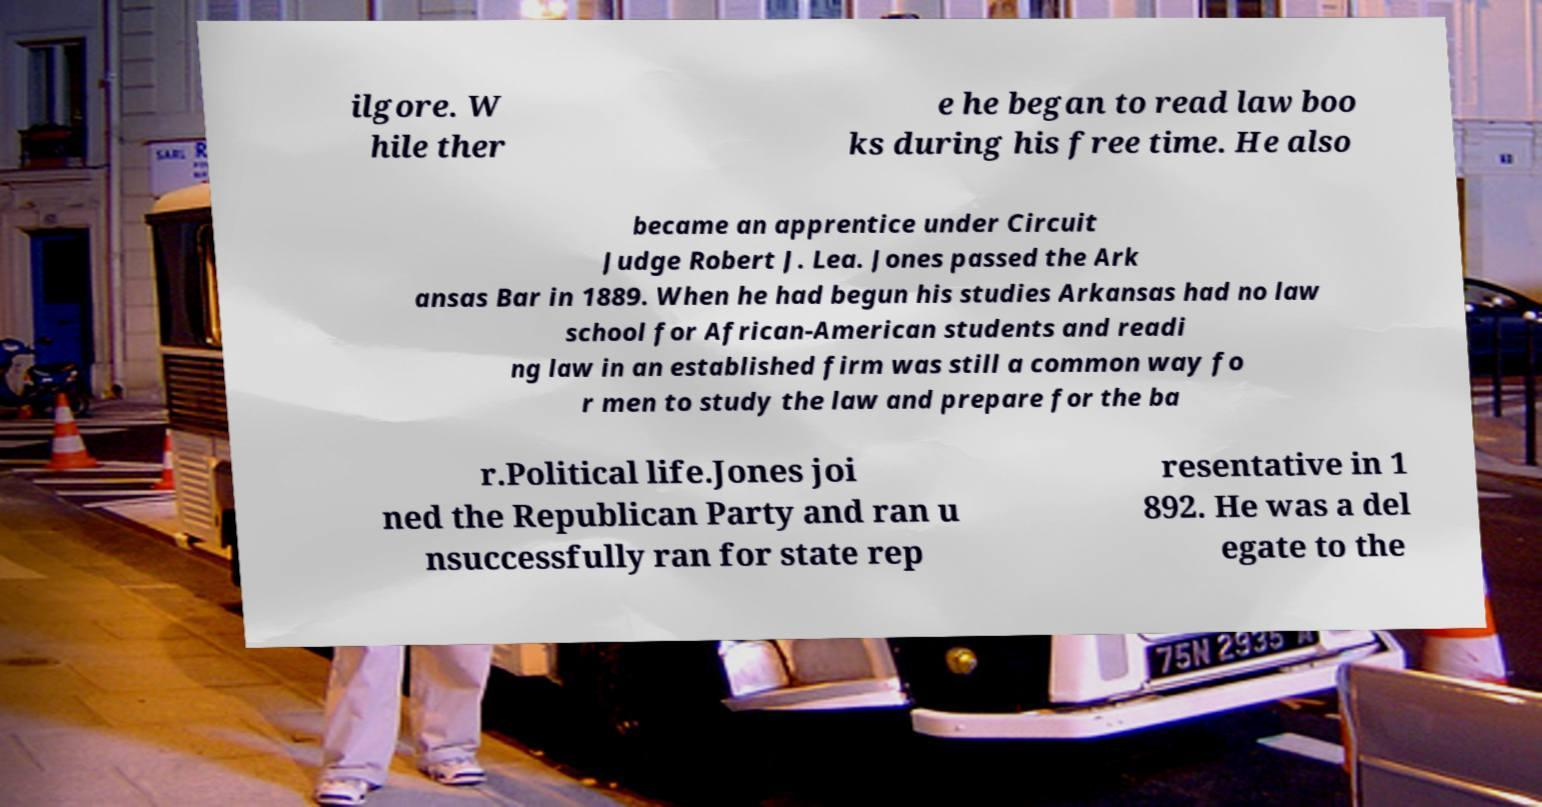Can you read and provide the text displayed in the image?This photo seems to have some interesting text. Can you extract and type it out for me? ilgore. W hile ther e he began to read law boo ks during his free time. He also became an apprentice under Circuit Judge Robert J. Lea. Jones passed the Ark ansas Bar in 1889. When he had begun his studies Arkansas had no law school for African-American students and readi ng law in an established firm was still a common way fo r men to study the law and prepare for the ba r.Political life.Jones joi ned the Republican Party and ran u nsuccessfully ran for state rep resentative in 1 892. He was a del egate to the 